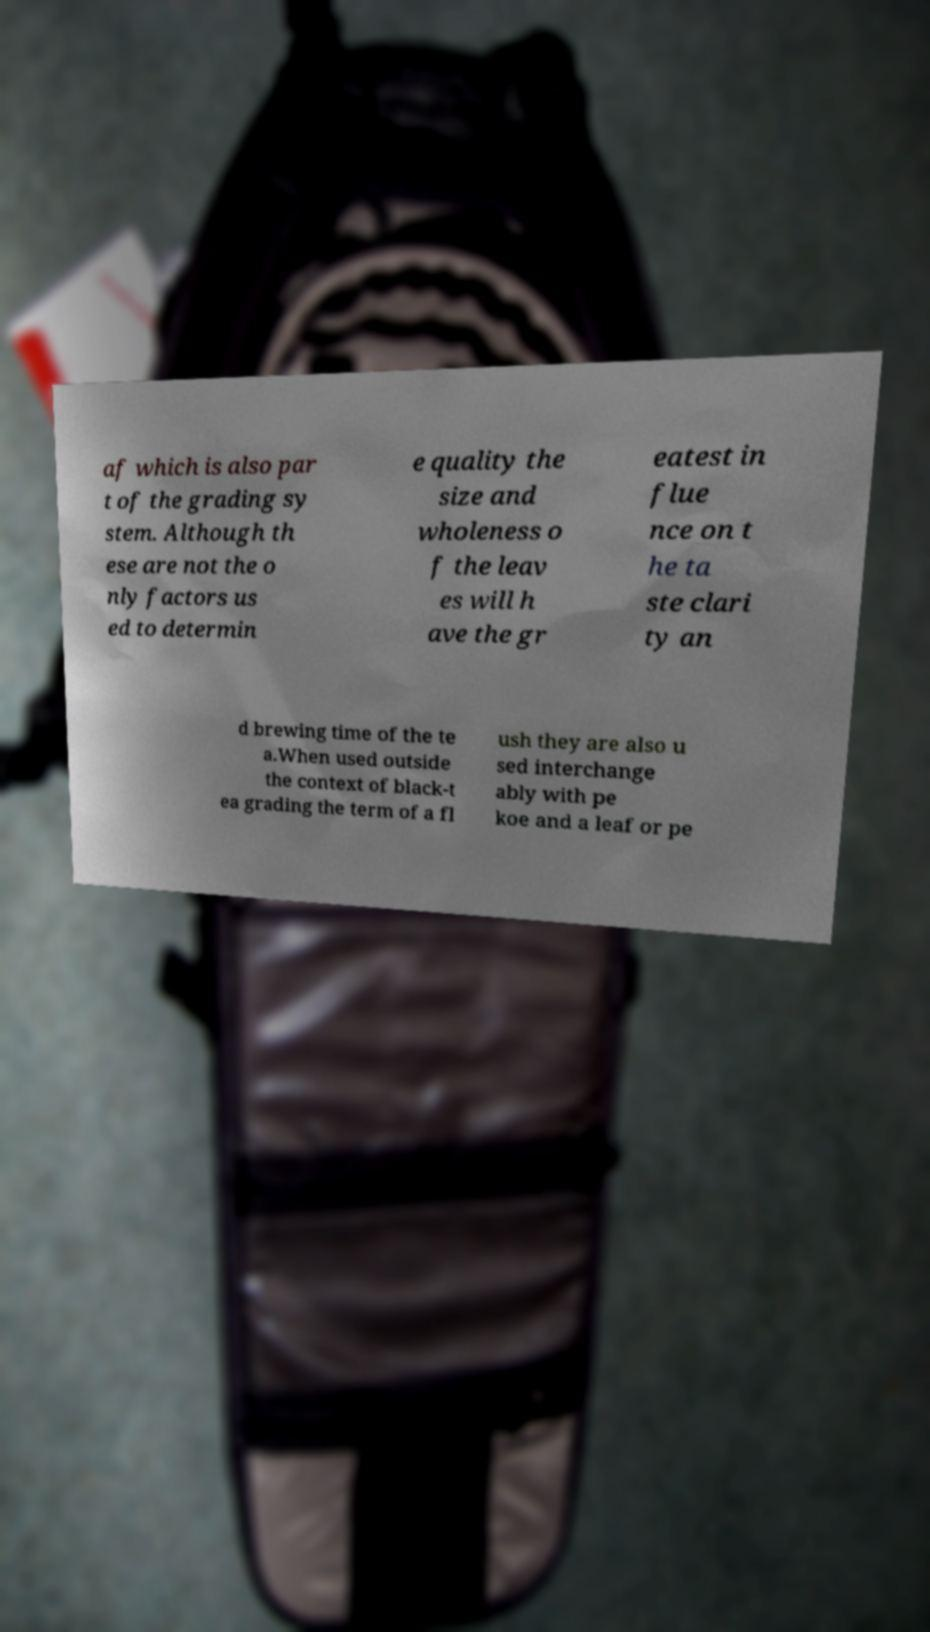Please read and relay the text visible in this image. What does it say? af which is also par t of the grading sy stem. Although th ese are not the o nly factors us ed to determin e quality the size and wholeness o f the leav es will h ave the gr eatest in flue nce on t he ta ste clari ty an d brewing time of the te a.When used outside the context of black-t ea grading the term of a fl ush they are also u sed interchange ably with pe koe and a leaf or pe 